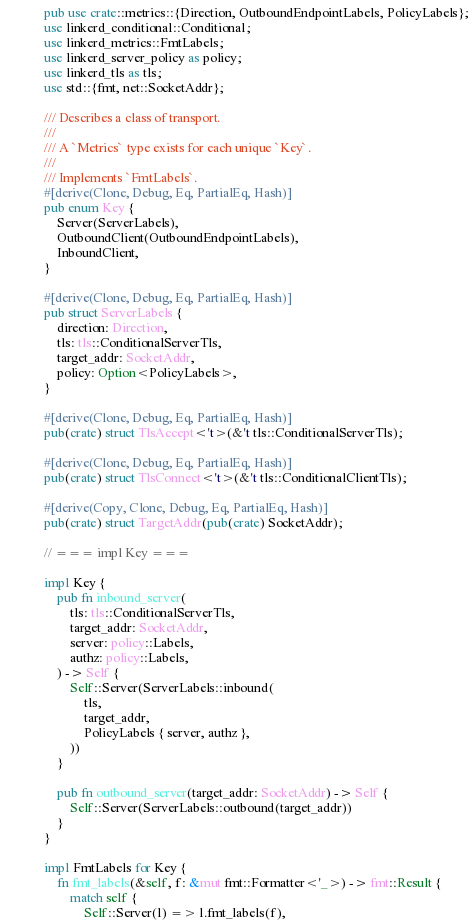<code> <loc_0><loc_0><loc_500><loc_500><_Rust_>pub use crate::metrics::{Direction, OutboundEndpointLabels, PolicyLabels};
use linkerd_conditional::Conditional;
use linkerd_metrics::FmtLabels;
use linkerd_server_policy as policy;
use linkerd_tls as tls;
use std::{fmt, net::SocketAddr};

/// Describes a class of transport.
///
/// A `Metrics` type exists for each unique `Key`.
///
/// Implements `FmtLabels`.
#[derive(Clone, Debug, Eq, PartialEq, Hash)]
pub enum Key {
    Server(ServerLabels),
    OutboundClient(OutboundEndpointLabels),
    InboundClient,
}

#[derive(Clone, Debug, Eq, PartialEq, Hash)]
pub struct ServerLabels {
    direction: Direction,
    tls: tls::ConditionalServerTls,
    target_addr: SocketAddr,
    policy: Option<PolicyLabels>,
}

#[derive(Clone, Debug, Eq, PartialEq, Hash)]
pub(crate) struct TlsAccept<'t>(&'t tls::ConditionalServerTls);

#[derive(Clone, Debug, Eq, PartialEq, Hash)]
pub(crate) struct TlsConnect<'t>(&'t tls::ConditionalClientTls);

#[derive(Copy, Clone, Debug, Eq, PartialEq, Hash)]
pub(crate) struct TargetAddr(pub(crate) SocketAddr);

// === impl Key ===

impl Key {
    pub fn inbound_server(
        tls: tls::ConditionalServerTls,
        target_addr: SocketAddr,
        server: policy::Labels,
        authz: policy::Labels,
    ) -> Self {
        Self::Server(ServerLabels::inbound(
            tls,
            target_addr,
            PolicyLabels { server, authz },
        ))
    }

    pub fn outbound_server(target_addr: SocketAddr) -> Self {
        Self::Server(ServerLabels::outbound(target_addr))
    }
}

impl FmtLabels for Key {
    fn fmt_labels(&self, f: &mut fmt::Formatter<'_>) -> fmt::Result {
        match self {
            Self::Server(l) => l.fmt_labels(f),
</code> 